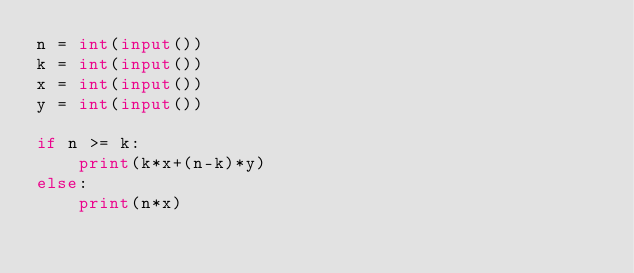Convert code to text. <code><loc_0><loc_0><loc_500><loc_500><_Python_>n = int(input())
k = int(input())
x = int(input())
y = int(input())

if n >= k:
    print(k*x+(n-k)*y)
else:
    print(n*x) </code> 